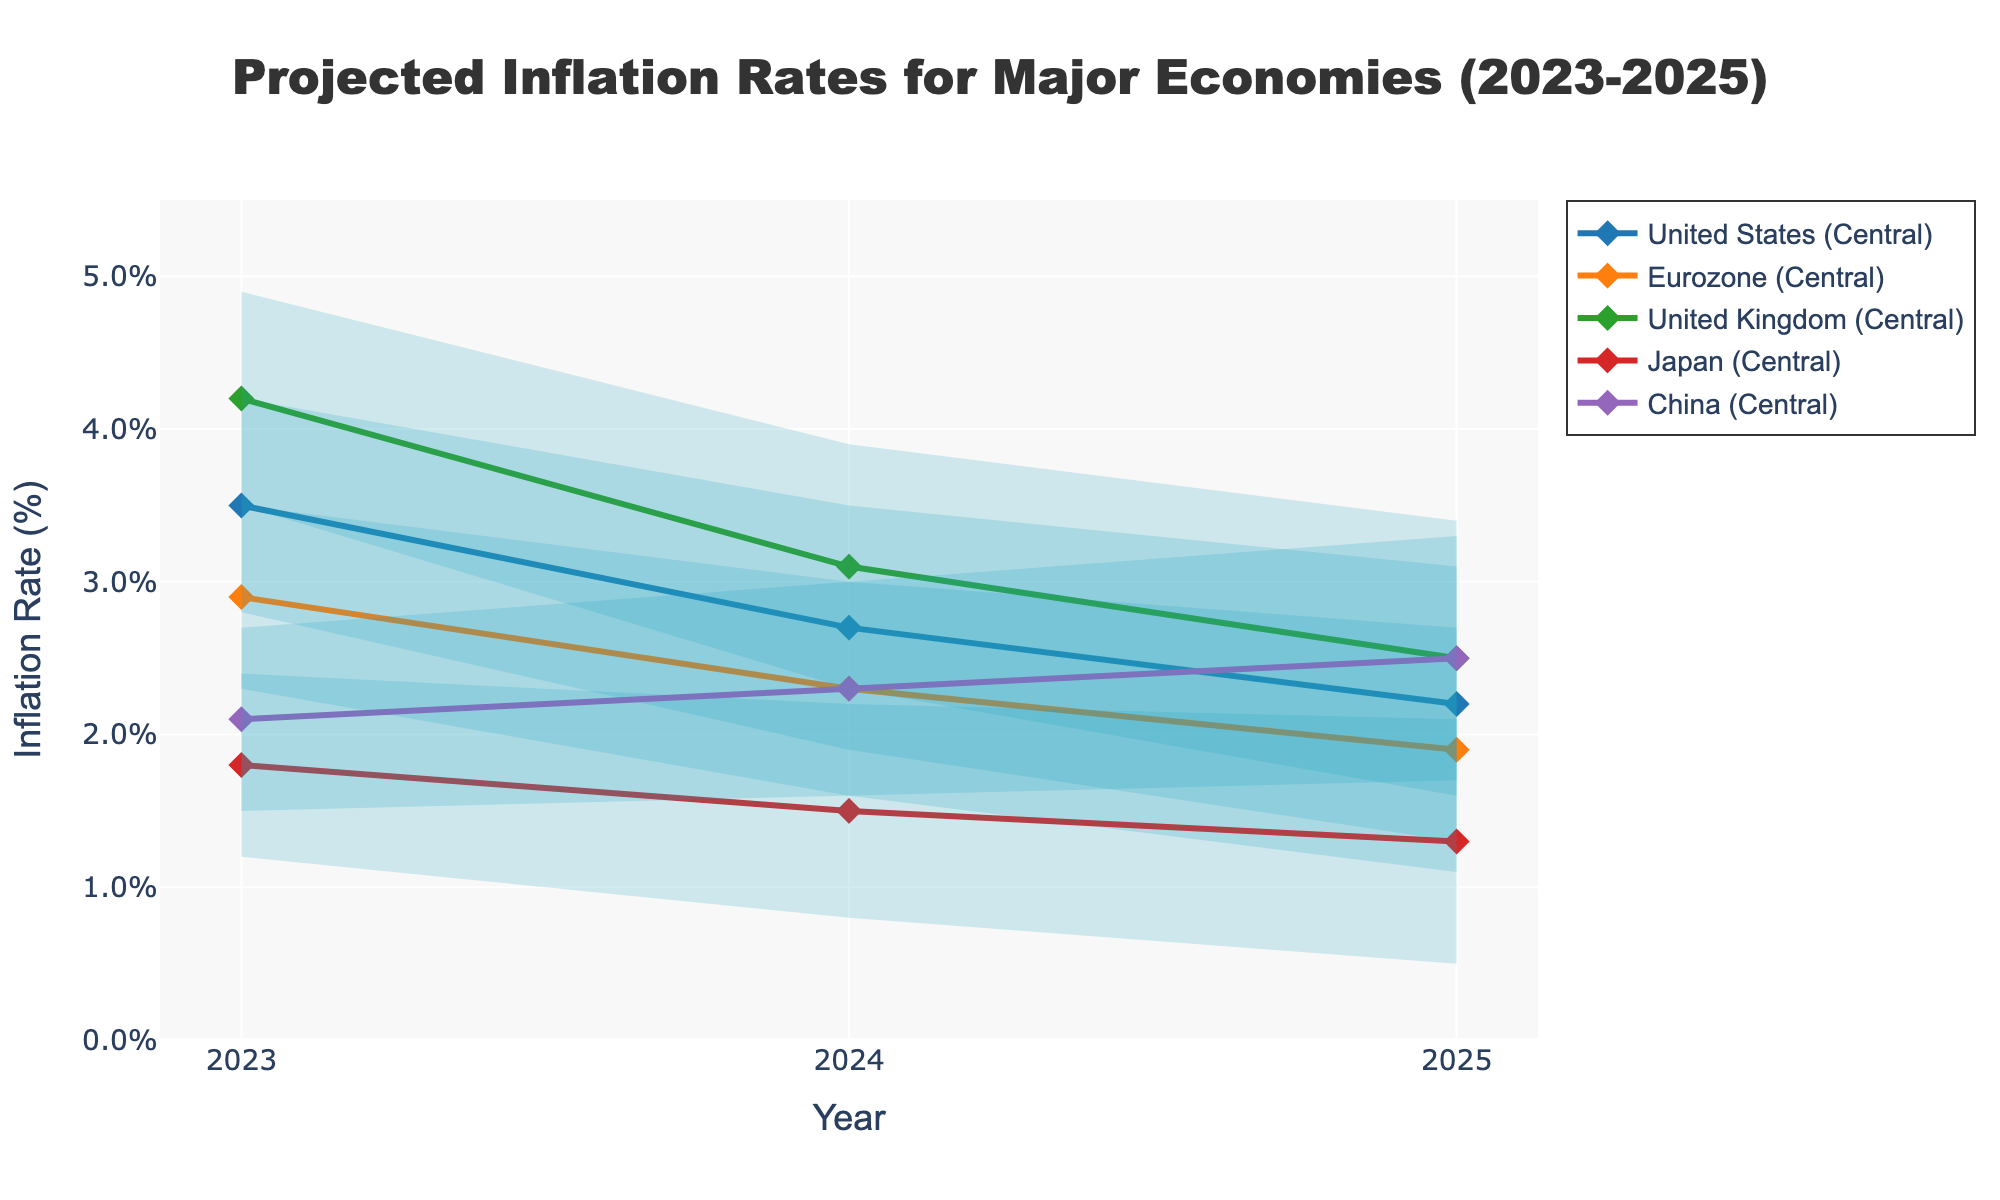What is the projected inflation rate for the United States in 2024? The central projection line shows the rates for each year. For the United States in 2024, the Central Projection value is given.
Answer: 2.7% Which country has the highest projected inflation rate in 2023? By looking at the central projection lines for 2023, the United Kingdom has the highest value compared to the other countries.
Answer: United Kingdom How much is the inflation rate uncertainty range for Japan in 2024? The uncertainty range can be calculated by subtracting the Lower Bound from the Upper Bound for Japan in 2024: 2.2 - 0.8.
Answer: 1.4% What is the trend in projected inflation rates for China from 2023 to 2025? Examining the central projection line for China over the years 2023, 2024, and 2025, note whether the values increase, decrease, or remain constant.
Answer: Increasing Which country has the smallest uncertainty range in 2025? Compare the differences between Upper Bound and Lower Bound for all countries in 2025 to determine which is smallest. Japan shows the smallest range (2.1 - 0.5).
Answer: Japan Is the projected inflation rate for the Eurozone in 2023 higher or lower than the United States? Compare the central projection values for both the Eurozone and the United States in 2023. The Eurozone has a value of 2.9%, and the United States has a value of 3.5%.
Answer: Lower How does the projected inflation rate for the United Kingdom change from 2023 to 2025? Observe the central projection line for the United Kingdom over the years 2023 to 2025. The rates decrease from 4.2% in 2023 to 3.1% in 2024 and 2.5% in 2025.
Answer: Decreasing What is the average uncertainty range for the United States from 2023 to 2025? Calculate the uncertainty ranges for the United States for each year and then find the average: (4.2-2.8)+(3.5-1.9)+(3.1-1.3). Then divide by 3. (1.4 + 1.6 + 1.8)/3.
Answer: 1.6% Which country's inflation rate has a higher upper bound in 2025, China or the Eurozone? Compare the upper bound values for China and the Eurozone in 2025. China has 3.3%, and the Eurozone has 2.7%.
Answer: China What is the projected inflation rate trend for Japan in this period? Observe the central projection line for Japan from 2023 to 2025. The values decrease from 1.8%, 1.5%, to 1.3%, indicating a decreasing trend.
Answer: Decreasing 